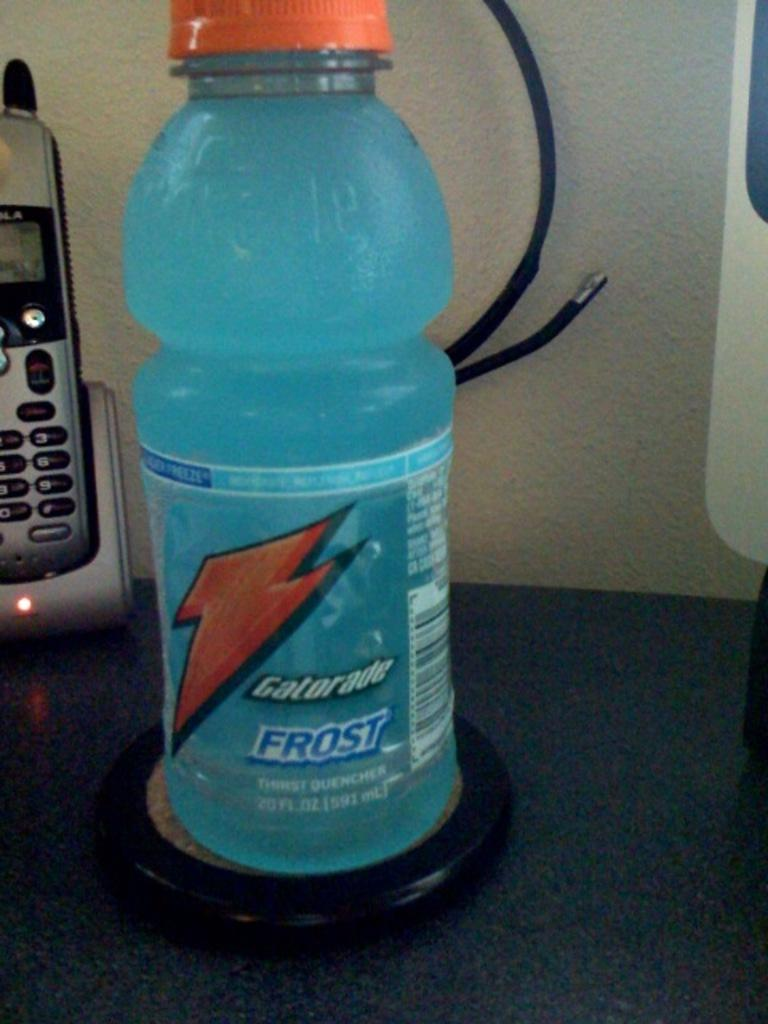<image>
Relay a brief, clear account of the picture shown. A Gatorade frost is on a black coaster. 